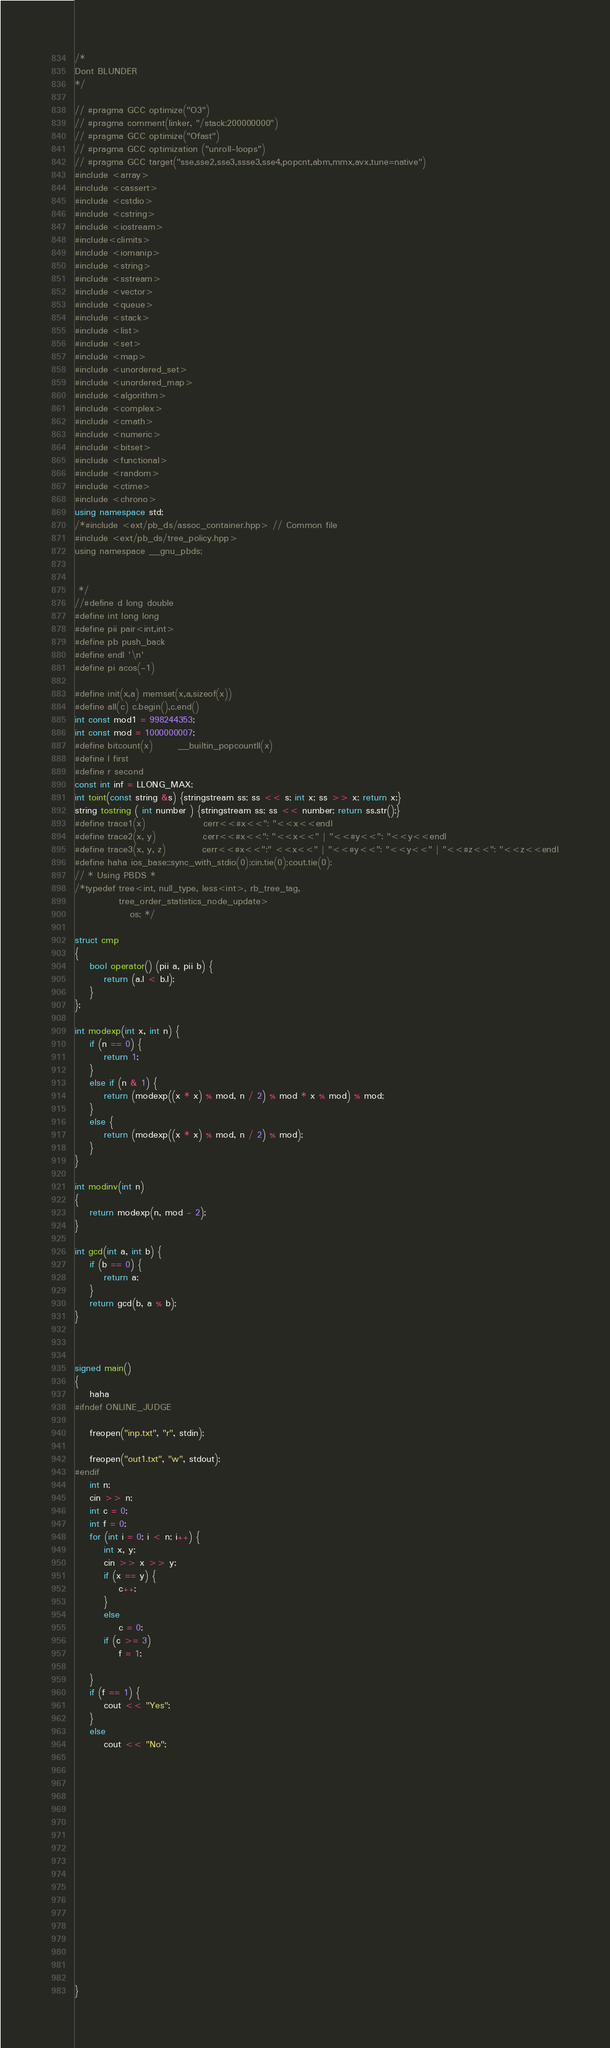<code> <loc_0><loc_0><loc_500><loc_500><_C++_>/*
Dont BLUNDER
*/

// #pragma GCC optimize("O3")
// #pragma comment(linker, "/stack:200000000")
// #pragma GCC optimize("Ofast")
// #pragma GCC optimization ("unroll-loops")
// #pragma GCC target("sse,sse2,sse3,ssse3,sse4,popcnt,abm,mmx,avx,tune=native")
#include <array>
#include <cassert>
#include <cstdio>
#include <cstring>
#include <iostream>
#include<climits>
#include <iomanip>
#include <string>
#include <sstream>
#include <vector>
#include <queue>
#include <stack>
#include <list>
#include <set>
#include <map>
#include <unordered_set>
#include <unordered_map>
#include <algorithm>
#include <complex>
#include <cmath>
#include <numeric>
#include <bitset>
#include <functional>
#include <random>
#include <ctime>
#include <chrono>
using namespace std;
/*#include <ext/pb_ds/assoc_container.hpp> // Common file
#include <ext/pb_ds/tree_policy.hpp>
using namespace __gnu_pbds;


 */
//#define d long double
#define int long long
#define pii pair<int,int>
#define pb push_back
#define endl '\n'
#define pi acos(-1)

#define init(x,a) memset(x,a,sizeof(x))
#define all(c) c.begin(),c.end()
int const mod1 = 998244353;
int const mod = 1000000007;
#define bitcount(x)       __builtin_popcountll(x)
#define l first
#define r second
const int inf = LLONG_MAX;
int toint(const string &s) {stringstream ss; ss << s; int x; ss >> x; return x;}
string tostring ( int number ) {stringstream ss; ss << number; return ss.str();}
#define trace1(x)                cerr<<#x<<": "<<x<<endl
#define trace2(x, y)             cerr<<#x<<": "<<x<<" | "<<#y<<": "<<y<<endl
#define trace3(x, y, z)          cerr<<#x<<":" <<x<<" | "<<#y<<": "<<y<<" | "<<#z<<": "<<z<<endl
#define haha ios_base::sync_with_stdio(0);cin.tie(0);cout.tie(0);
// * Using PBDS *
/*typedef tree<int, null_type, less<int>, rb_tree_tag,
            tree_order_statistics_node_update>
               os; */

struct cmp
{
	bool operator() (pii a, pii b) {
		return (a.l < b.l);
	}
};

int modexp(int x, int n) {
	if (n == 0) {
		return 1;
	}
	else if (n & 1) {
		return (modexp((x * x) % mod, n / 2) % mod * x % mod) % mod;
	}
	else {
		return (modexp((x * x) % mod, n / 2) % mod);
	}
}

int modinv(int n)
{
	return modexp(n, mod - 2);
}

int gcd(int a, int b) {
	if (b == 0) {
		return a;
	}
	return gcd(b, a % b);
}



signed main()
{
	haha
#ifndef ONLINE_JUDGE

	freopen("inp.txt", "r", stdin);

	freopen("out1.txt", "w", stdout);
#endif
	int n;
	cin >> n;
	int c = 0;
	int f = 0;
	for (int i = 0; i < n; i++) {
		int x, y;
		cin >> x >> y;
		if (x == y) {
			c++;
		}
		else
			c = 0;
		if (c >= 3)
			f = 1;

	}
	if (f == 1) {
		cout << "Yes";
	}
	else
		cout << "No";


















}
</code> 